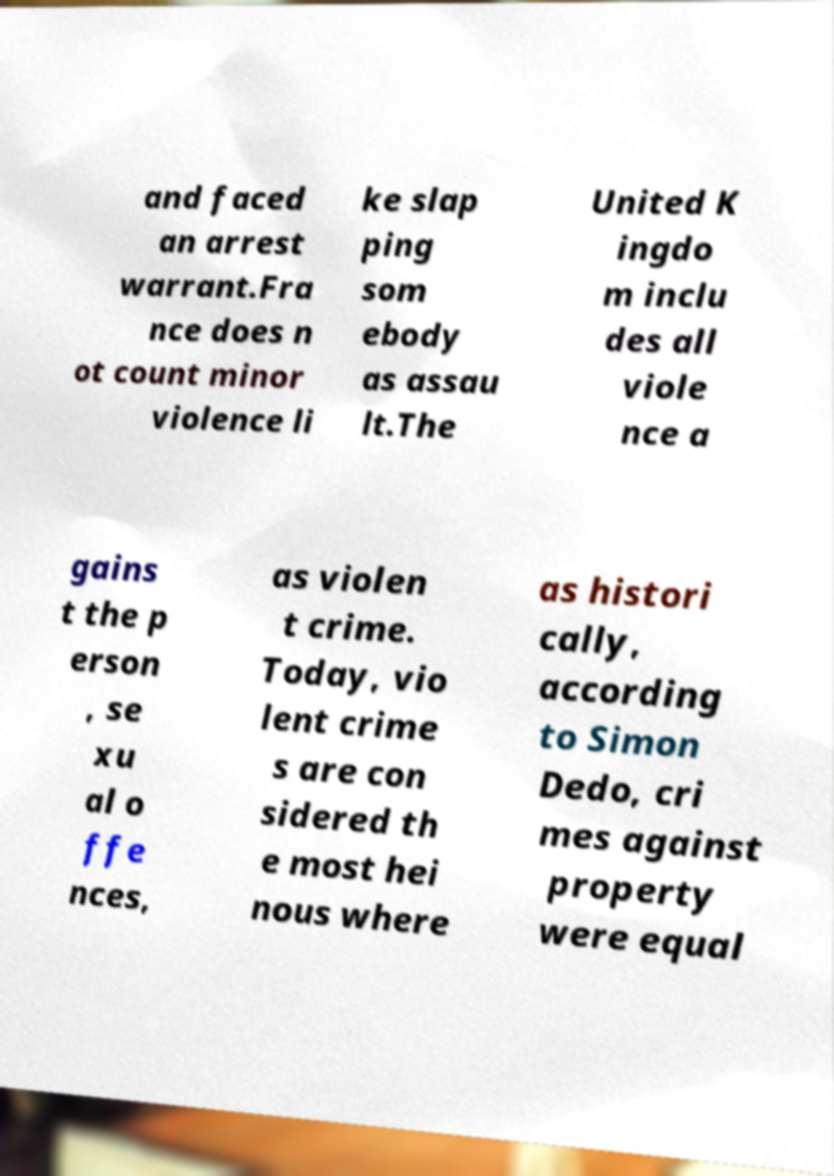Can you accurately transcribe the text from the provided image for me? and faced an arrest warrant.Fra nce does n ot count minor violence li ke slap ping som ebody as assau lt.The United K ingdo m inclu des all viole nce a gains t the p erson , se xu al o ffe nces, as violen t crime. Today, vio lent crime s are con sidered th e most hei nous where as histori cally, according to Simon Dedo, cri mes against property were equal 